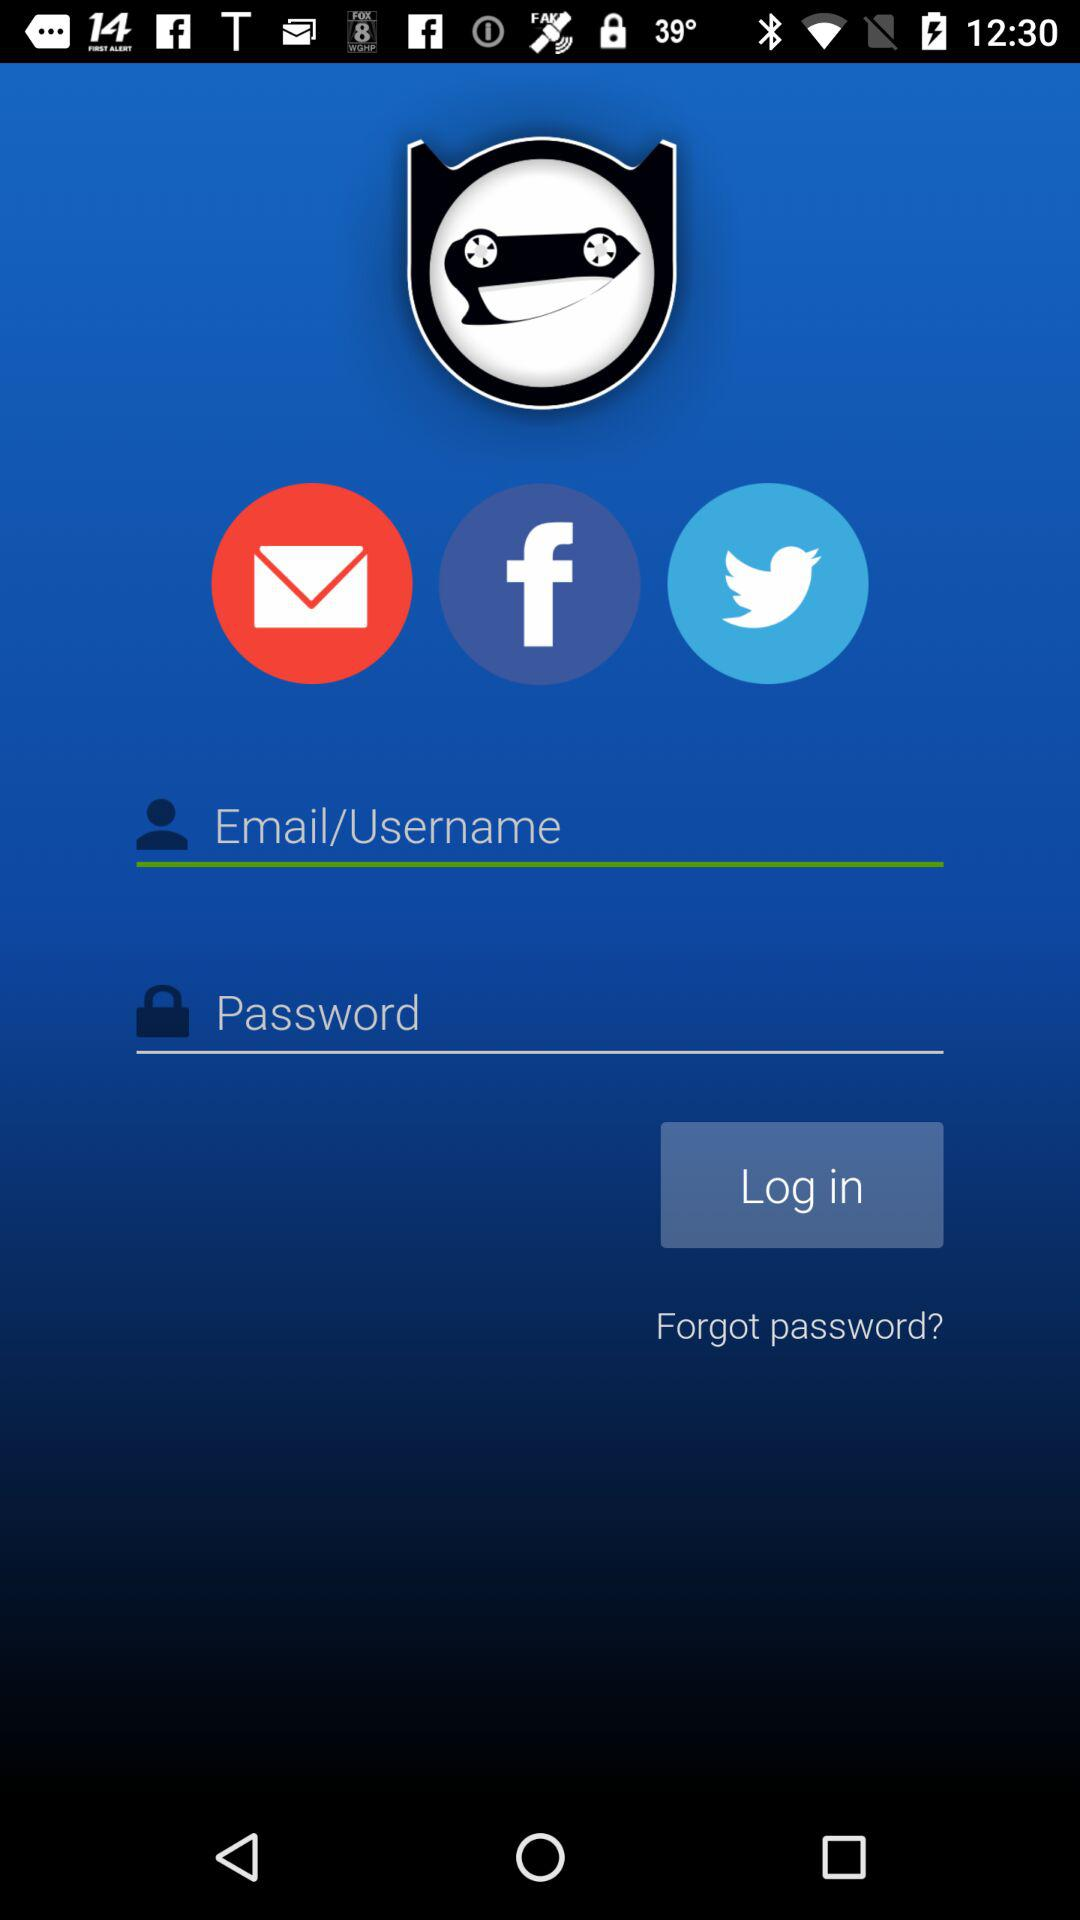What are the requirements to get a login? The requirements to get a login are "Email/Username" and "Password". 